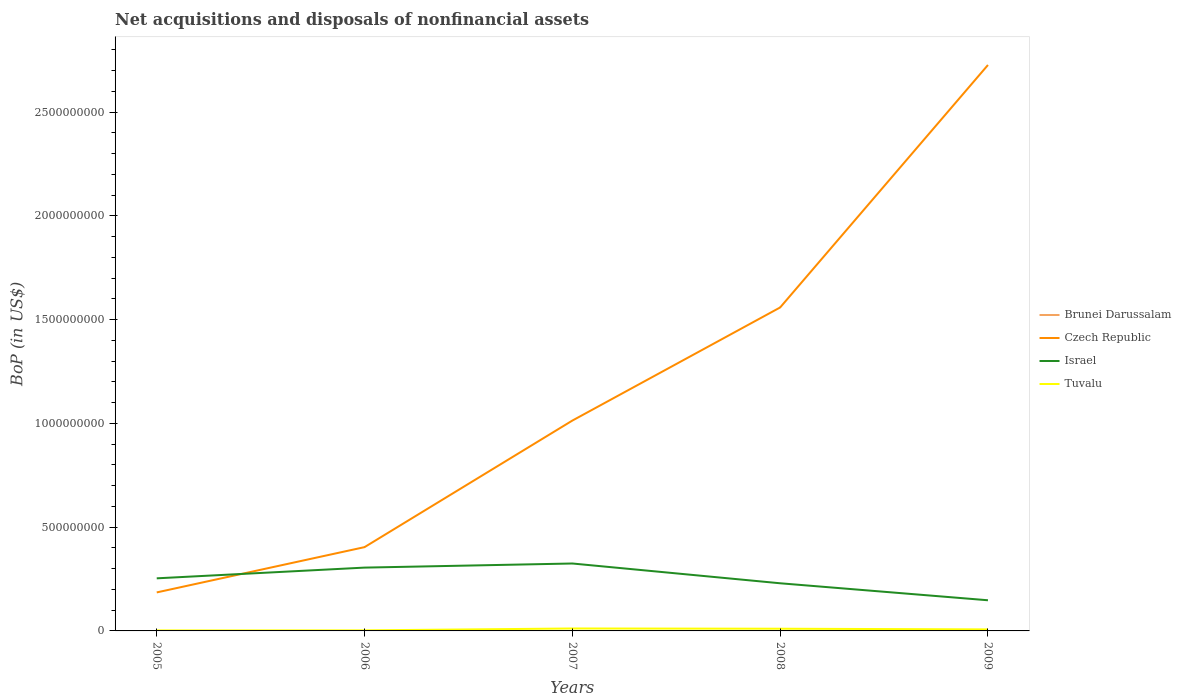Across all years, what is the maximum Balance of Payments in Czech Republic?
Provide a short and direct response. 1.86e+08. What is the total Balance of Payments in Czech Republic in the graph?
Your response must be concise. -2.18e+08. What is the difference between the highest and the second highest Balance of Payments in Israel?
Give a very brief answer. 1.77e+08. What is the difference between the highest and the lowest Balance of Payments in Tuvalu?
Provide a short and direct response. 3. Is the Balance of Payments in Brunei Darussalam strictly greater than the Balance of Payments in Tuvalu over the years?
Offer a very short reply. Yes. What is the difference between two consecutive major ticks on the Y-axis?
Your answer should be very brief. 5.00e+08. Does the graph contain grids?
Offer a very short reply. No. Where does the legend appear in the graph?
Keep it short and to the point. Center right. What is the title of the graph?
Ensure brevity in your answer.  Net acquisitions and disposals of nonfinancial assets. What is the label or title of the Y-axis?
Your answer should be very brief. BoP (in US$). What is the BoP (in US$) of Czech Republic in 2005?
Ensure brevity in your answer.  1.86e+08. What is the BoP (in US$) in Israel in 2005?
Offer a terse response. 2.53e+08. What is the BoP (in US$) of Tuvalu in 2005?
Offer a very short reply. 2.42e+06. What is the BoP (in US$) of Brunei Darussalam in 2006?
Provide a short and direct response. 0. What is the BoP (in US$) in Czech Republic in 2006?
Give a very brief answer. 4.04e+08. What is the BoP (in US$) in Israel in 2006?
Keep it short and to the point. 3.05e+08. What is the BoP (in US$) of Tuvalu in 2006?
Provide a succinct answer. 2.68e+06. What is the BoP (in US$) of Czech Republic in 2007?
Keep it short and to the point. 1.01e+09. What is the BoP (in US$) in Israel in 2007?
Ensure brevity in your answer.  3.25e+08. What is the BoP (in US$) of Tuvalu in 2007?
Make the answer very short. 1.18e+07. What is the BoP (in US$) in Brunei Darussalam in 2008?
Your answer should be very brief. 0. What is the BoP (in US$) in Czech Republic in 2008?
Offer a terse response. 1.56e+09. What is the BoP (in US$) in Israel in 2008?
Make the answer very short. 2.30e+08. What is the BoP (in US$) in Tuvalu in 2008?
Keep it short and to the point. 1.06e+07. What is the BoP (in US$) in Czech Republic in 2009?
Your answer should be compact. 2.73e+09. What is the BoP (in US$) of Israel in 2009?
Keep it short and to the point. 1.48e+08. What is the BoP (in US$) of Tuvalu in 2009?
Your answer should be very brief. 7.29e+06. Across all years, what is the maximum BoP (in US$) of Czech Republic?
Give a very brief answer. 2.73e+09. Across all years, what is the maximum BoP (in US$) of Israel?
Ensure brevity in your answer.  3.25e+08. Across all years, what is the maximum BoP (in US$) in Tuvalu?
Your answer should be very brief. 1.18e+07. Across all years, what is the minimum BoP (in US$) in Czech Republic?
Make the answer very short. 1.86e+08. Across all years, what is the minimum BoP (in US$) in Israel?
Keep it short and to the point. 1.48e+08. Across all years, what is the minimum BoP (in US$) of Tuvalu?
Your response must be concise. 2.42e+06. What is the total BoP (in US$) of Czech Republic in the graph?
Your answer should be very brief. 5.89e+09. What is the total BoP (in US$) in Israel in the graph?
Make the answer very short. 1.26e+09. What is the total BoP (in US$) of Tuvalu in the graph?
Your answer should be very brief. 3.48e+07. What is the difference between the BoP (in US$) in Czech Republic in 2005 and that in 2006?
Your response must be concise. -2.18e+08. What is the difference between the BoP (in US$) in Israel in 2005 and that in 2006?
Provide a short and direct response. -5.17e+07. What is the difference between the BoP (in US$) in Tuvalu in 2005 and that in 2006?
Offer a very short reply. -2.60e+05. What is the difference between the BoP (in US$) in Czech Republic in 2005 and that in 2007?
Your answer should be compact. -8.28e+08. What is the difference between the BoP (in US$) of Israel in 2005 and that in 2007?
Provide a succinct answer. -7.15e+07. What is the difference between the BoP (in US$) of Tuvalu in 2005 and that in 2007?
Your answer should be compact. -9.35e+06. What is the difference between the BoP (in US$) of Czech Republic in 2005 and that in 2008?
Ensure brevity in your answer.  -1.37e+09. What is the difference between the BoP (in US$) of Israel in 2005 and that in 2008?
Offer a very short reply. 2.38e+07. What is the difference between the BoP (in US$) in Tuvalu in 2005 and that in 2008?
Your answer should be compact. -8.19e+06. What is the difference between the BoP (in US$) in Czech Republic in 2005 and that in 2009?
Make the answer very short. -2.54e+09. What is the difference between the BoP (in US$) of Israel in 2005 and that in 2009?
Offer a terse response. 1.06e+08. What is the difference between the BoP (in US$) of Tuvalu in 2005 and that in 2009?
Ensure brevity in your answer.  -4.87e+06. What is the difference between the BoP (in US$) in Czech Republic in 2006 and that in 2007?
Give a very brief answer. -6.10e+08. What is the difference between the BoP (in US$) of Israel in 2006 and that in 2007?
Your response must be concise. -1.98e+07. What is the difference between the BoP (in US$) of Tuvalu in 2006 and that in 2007?
Ensure brevity in your answer.  -9.09e+06. What is the difference between the BoP (in US$) of Czech Republic in 2006 and that in 2008?
Ensure brevity in your answer.  -1.15e+09. What is the difference between the BoP (in US$) of Israel in 2006 and that in 2008?
Provide a succinct answer. 7.55e+07. What is the difference between the BoP (in US$) in Tuvalu in 2006 and that in 2008?
Make the answer very short. -7.93e+06. What is the difference between the BoP (in US$) of Czech Republic in 2006 and that in 2009?
Provide a short and direct response. -2.32e+09. What is the difference between the BoP (in US$) of Israel in 2006 and that in 2009?
Offer a very short reply. 1.57e+08. What is the difference between the BoP (in US$) of Tuvalu in 2006 and that in 2009?
Offer a terse response. -4.61e+06. What is the difference between the BoP (in US$) of Czech Republic in 2007 and that in 2008?
Make the answer very short. -5.45e+08. What is the difference between the BoP (in US$) in Israel in 2007 and that in 2008?
Offer a very short reply. 9.53e+07. What is the difference between the BoP (in US$) of Tuvalu in 2007 and that in 2008?
Provide a succinct answer. 1.16e+06. What is the difference between the BoP (in US$) of Czech Republic in 2007 and that in 2009?
Keep it short and to the point. -1.71e+09. What is the difference between the BoP (in US$) of Israel in 2007 and that in 2009?
Give a very brief answer. 1.77e+08. What is the difference between the BoP (in US$) of Tuvalu in 2007 and that in 2009?
Provide a short and direct response. 4.48e+06. What is the difference between the BoP (in US$) in Czech Republic in 2008 and that in 2009?
Provide a succinct answer. -1.17e+09. What is the difference between the BoP (in US$) in Israel in 2008 and that in 2009?
Ensure brevity in your answer.  8.19e+07. What is the difference between the BoP (in US$) in Tuvalu in 2008 and that in 2009?
Offer a terse response. 3.32e+06. What is the difference between the BoP (in US$) of Czech Republic in 2005 and the BoP (in US$) of Israel in 2006?
Keep it short and to the point. -1.20e+08. What is the difference between the BoP (in US$) in Czech Republic in 2005 and the BoP (in US$) in Tuvalu in 2006?
Ensure brevity in your answer.  1.83e+08. What is the difference between the BoP (in US$) of Israel in 2005 and the BoP (in US$) of Tuvalu in 2006?
Provide a short and direct response. 2.51e+08. What is the difference between the BoP (in US$) in Czech Republic in 2005 and the BoP (in US$) in Israel in 2007?
Your answer should be compact. -1.39e+08. What is the difference between the BoP (in US$) of Czech Republic in 2005 and the BoP (in US$) of Tuvalu in 2007?
Your answer should be very brief. 1.74e+08. What is the difference between the BoP (in US$) of Israel in 2005 and the BoP (in US$) of Tuvalu in 2007?
Provide a succinct answer. 2.42e+08. What is the difference between the BoP (in US$) of Czech Republic in 2005 and the BoP (in US$) of Israel in 2008?
Your answer should be very brief. -4.41e+07. What is the difference between the BoP (in US$) in Czech Republic in 2005 and the BoP (in US$) in Tuvalu in 2008?
Ensure brevity in your answer.  1.75e+08. What is the difference between the BoP (in US$) of Israel in 2005 and the BoP (in US$) of Tuvalu in 2008?
Provide a succinct answer. 2.43e+08. What is the difference between the BoP (in US$) of Czech Republic in 2005 and the BoP (in US$) of Israel in 2009?
Provide a short and direct response. 3.78e+07. What is the difference between the BoP (in US$) of Czech Republic in 2005 and the BoP (in US$) of Tuvalu in 2009?
Ensure brevity in your answer.  1.78e+08. What is the difference between the BoP (in US$) of Israel in 2005 and the BoP (in US$) of Tuvalu in 2009?
Offer a terse response. 2.46e+08. What is the difference between the BoP (in US$) of Czech Republic in 2006 and the BoP (in US$) of Israel in 2007?
Provide a succinct answer. 7.88e+07. What is the difference between the BoP (in US$) in Czech Republic in 2006 and the BoP (in US$) in Tuvalu in 2007?
Provide a succinct answer. 3.92e+08. What is the difference between the BoP (in US$) in Israel in 2006 and the BoP (in US$) in Tuvalu in 2007?
Keep it short and to the point. 2.93e+08. What is the difference between the BoP (in US$) of Czech Republic in 2006 and the BoP (in US$) of Israel in 2008?
Offer a terse response. 1.74e+08. What is the difference between the BoP (in US$) of Czech Republic in 2006 and the BoP (in US$) of Tuvalu in 2008?
Provide a short and direct response. 3.93e+08. What is the difference between the BoP (in US$) of Israel in 2006 and the BoP (in US$) of Tuvalu in 2008?
Your answer should be compact. 2.94e+08. What is the difference between the BoP (in US$) in Czech Republic in 2006 and the BoP (in US$) in Israel in 2009?
Offer a very short reply. 2.56e+08. What is the difference between the BoP (in US$) of Czech Republic in 2006 and the BoP (in US$) of Tuvalu in 2009?
Provide a short and direct response. 3.96e+08. What is the difference between the BoP (in US$) of Israel in 2006 and the BoP (in US$) of Tuvalu in 2009?
Offer a very short reply. 2.98e+08. What is the difference between the BoP (in US$) in Czech Republic in 2007 and the BoP (in US$) in Israel in 2008?
Provide a short and direct response. 7.84e+08. What is the difference between the BoP (in US$) in Czech Republic in 2007 and the BoP (in US$) in Tuvalu in 2008?
Ensure brevity in your answer.  1.00e+09. What is the difference between the BoP (in US$) in Israel in 2007 and the BoP (in US$) in Tuvalu in 2008?
Make the answer very short. 3.14e+08. What is the difference between the BoP (in US$) in Czech Republic in 2007 and the BoP (in US$) in Israel in 2009?
Provide a short and direct response. 8.66e+08. What is the difference between the BoP (in US$) of Czech Republic in 2007 and the BoP (in US$) of Tuvalu in 2009?
Provide a succinct answer. 1.01e+09. What is the difference between the BoP (in US$) of Israel in 2007 and the BoP (in US$) of Tuvalu in 2009?
Keep it short and to the point. 3.18e+08. What is the difference between the BoP (in US$) of Czech Republic in 2008 and the BoP (in US$) of Israel in 2009?
Ensure brevity in your answer.  1.41e+09. What is the difference between the BoP (in US$) of Czech Republic in 2008 and the BoP (in US$) of Tuvalu in 2009?
Provide a short and direct response. 1.55e+09. What is the difference between the BoP (in US$) in Israel in 2008 and the BoP (in US$) in Tuvalu in 2009?
Your answer should be compact. 2.22e+08. What is the average BoP (in US$) in Brunei Darussalam per year?
Keep it short and to the point. 0. What is the average BoP (in US$) in Czech Republic per year?
Keep it short and to the point. 1.18e+09. What is the average BoP (in US$) of Israel per year?
Ensure brevity in your answer.  2.52e+08. What is the average BoP (in US$) in Tuvalu per year?
Offer a terse response. 6.95e+06. In the year 2005, what is the difference between the BoP (in US$) of Czech Republic and BoP (in US$) of Israel?
Your response must be concise. -6.79e+07. In the year 2005, what is the difference between the BoP (in US$) of Czech Republic and BoP (in US$) of Tuvalu?
Offer a terse response. 1.83e+08. In the year 2005, what is the difference between the BoP (in US$) in Israel and BoP (in US$) in Tuvalu?
Offer a terse response. 2.51e+08. In the year 2006, what is the difference between the BoP (in US$) of Czech Republic and BoP (in US$) of Israel?
Offer a terse response. 9.86e+07. In the year 2006, what is the difference between the BoP (in US$) in Czech Republic and BoP (in US$) in Tuvalu?
Give a very brief answer. 4.01e+08. In the year 2006, what is the difference between the BoP (in US$) of Israel and BoP (in US$) of Tuvalu?
Your response must be concise. 3.02e+08. In the year 2007, what is the difference between the BoP (in US$) of Czech Republic and BoP (in US$) of Israel?
Provide a short and direct response. 6.89e+08. In the year 2007, what is the difference between the BoP (in US$) of Czech Republic and BoP (in US$) of Tuvalu?
Offer a very short reply. 1.00e+09. In the year 2007, what is the difference between the BoP (in US$) of Israel and BoP (in US$) of Tuvalu?
Your answer should be compact. 3.13e+08. In the year 2008, what is the difference between the BoP (in US$) of Czech Republic and BoP (in US$) of Israel?
Your answer should be very brief. 1.33e+09. In the year 2008, what is the difference between the BoP (in US$) of Czech Republic and BoP (in US$) of Tuvalu?
Your answer should be very brief. 1.55e+09. In the year 2008, what is the difference between the BoP (in US$) of Israel and BoP (in US$) of Tuvalu?
Your answer should be very brief. 2.19e+08. In the year 2009, what is the difference between the BoP (in US$) of Czech Republic and BoP (in US$) of Israel?
Provide a short and direct response. 2.58e+09. In the year 2009, what is the difference between the BoP (in US$) in Czech Republic and BoP (in US$) in Tuvalu?
Make the answer very short. 2.72e+09. In the year 2009, what is the difference between the BoP (in US$) in Israel and BoP (in US$) in Tuvalu?
Your answer should be very brief. 1.40e+08. What is the ratio of the BoP (in US$) in Czech Republic in 2005 to that in 2006?
Ensure brevity in your answer.  0.46. What is the ratio of the BoP (in US$) of Israel in 2005 to that in 2006?
Your answer should be compact. 0.83. What is the ratio of the BoP (in US$) of Tuvalu in 2005 to that in 2006?
Make the answer very short. 0.9. What is the ratio of the BoP (in US$) of Czech Republic in 2005 to that in 2007?
Your response must be concise. 0.18. What is the ratio of the BoP (in US$) in Israel in 2005 to that in 2007?
Keep it short and to the point. 0.78. What is the ratio of the BoP (in US$) in Tuvalu in 2005 to that in 2007?
Make the answer very short. 0.21. What is the ratio of the BoP (in US$) in Czech Republic in 2005 to that in 2008?
Keep it short and to the point. 0.12. What is the ratio of the BoP (in US$) of Israel in 2005 to that in 2008?
Your answer should be compact. 1.1. What is the ratio of the BoP (in US$) in Tuvalu in 2005 to that in 2008?
Offer a very short reply. 0.23. What is the ratio of the BoP (in US$) of Czech Republic in 2005 to that in 2009?
Offer a very short reply. 0.07. What is the ratio of the BoP (in US$) in Israel in 2005 to that in 2009?
Provide a succinct answer. 1.72. What is the ratio of the BoP (in US$) in Tuvalu in 2005 to that in 2009?
Offer a terse response. 0.33. What is the ratio of the BoP (in US$) in Czech Republic in 2006 to that in 2007?
Provide a succinct answer. 0.4. What is the ratio of the BoP (in US$) of Israel in 2006 to that in 2007?
Your answer should be compact. 0.94. What is the ratio of the BoP (in US$) in Tuvalu in 2006 to that in 2007?
Offer a terse response. 0.23. What is the ratio of the BoP (in US$) in Czech Republic in 2006 to that in 2008?
Your response must be concise. 0.26. What is the ratio of the BoP (in US$) of Israel in 2006 to that in 2008?
Offer a very short reply. 1.33. What is the ratio of the BoP (in US$) of Tuvalu in 2006 to that in 2008?
Your answer should be compact. 0.25. What is the ratio of the BoP (in US$) of Czech Republic in 2006 to that in 2009?
Keep it short and to the point. 0.15. What is the ratio of the BoP (in US$) in Israel in 2006 to that in 2009?
Your response must be concise. 2.07. What is the ratio of the BoP (in US$) of Tuvalu in 2006 to that in 2009?
Your response must be concise. 0.37. What is the ratio of the BoP (in US$) of Czech Republic in 2007 to that in 2008?
Your response must be concise. 0.65. What is the ratio of the BoP (in US$) in Israel in 2007 to that in 2008?
Provide a short and direct response. 1.42. What is the ratio of the BoP (in US$) of Tuvalu in 2007 to that in 2008?
Offer a very short reply. 1.11. What is the ratio of the BoP (in US$) of Czech Republic in 2007 to that in 2009?
Ensure brevity in your answer.  0.37. What is the ratio of the BoP (in US$) of Israel in 2007 to that in 2009?
Make the answer very short. 2.2. What is the ratio of the BoP (in US$) in Tuvalu in 2007 to that in 2009?
Provide a succinct answer. 1.61. What is the ratio of the BoP (in US$) in Czech Republic in 2008 to that in 2009?
Make the answer very short. 0.57. What is the ratio of the BoP (in US$) in Israel in 2008 to that in 2009?
Your response must be concise. 1.55. What is the ratio of the BoP (in US$) in Tuvalu in 2008 to that in 2009?
Ensure brevity in your answer.  1.46. What is the difference between the highest and the second highest BoP (in US$) of Czech Republic?
Provide a short and direct response. 1.17e+09. What is the difference between the highest and the second highest BoP (in US$) of Israel?
Provide a short and direct response. 1.98e+07. What is the difference between the highest and the second highest BoP (in US$) in Tuvalu?
Ensure brevity in your answer.  1.16e+06. What is the difference between the highest and the lowest BoP (in US$) in Czech Republic?
Make the answer very short. 2.54e+09. What is the difference between the highest and the lowest BoP (in US$) of Israel?
Make the answer very short. 1.77e+08. What is the difference between the highest and the lowest BoP (in US$) in Tuvalu?
Ensure brevity in your answer.  9.35e+06. 